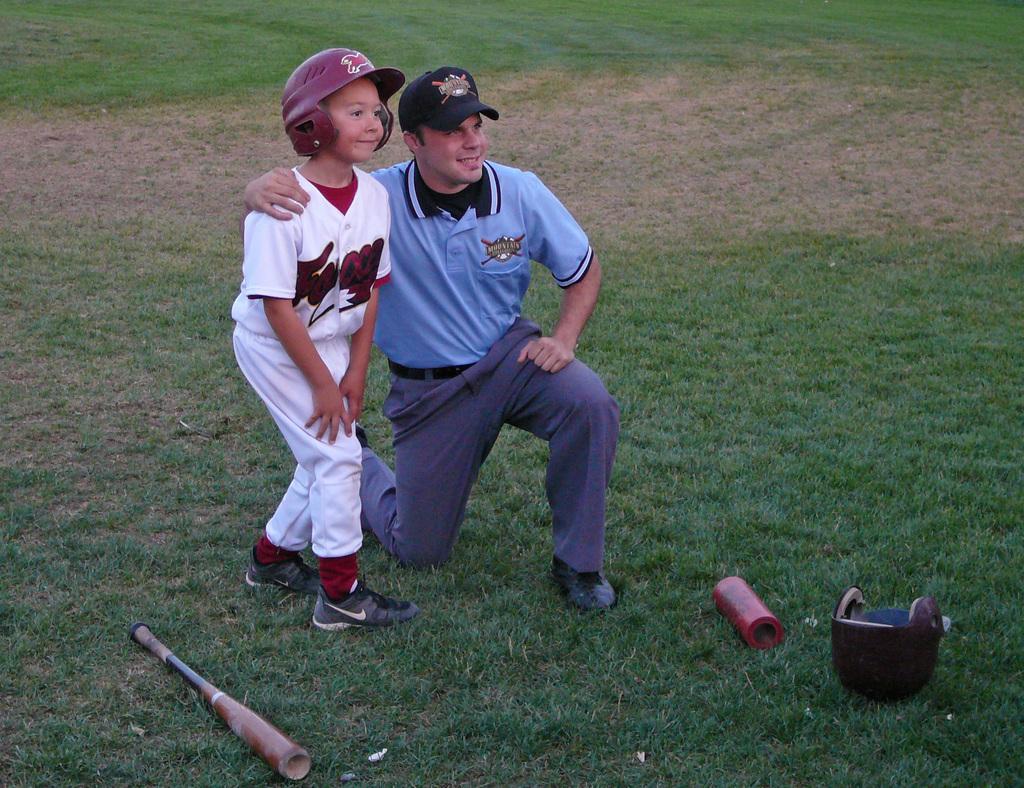Describe this image in one or two sentences. In this picture we can see two people smiling, bat, helmet and an object on the grass. 